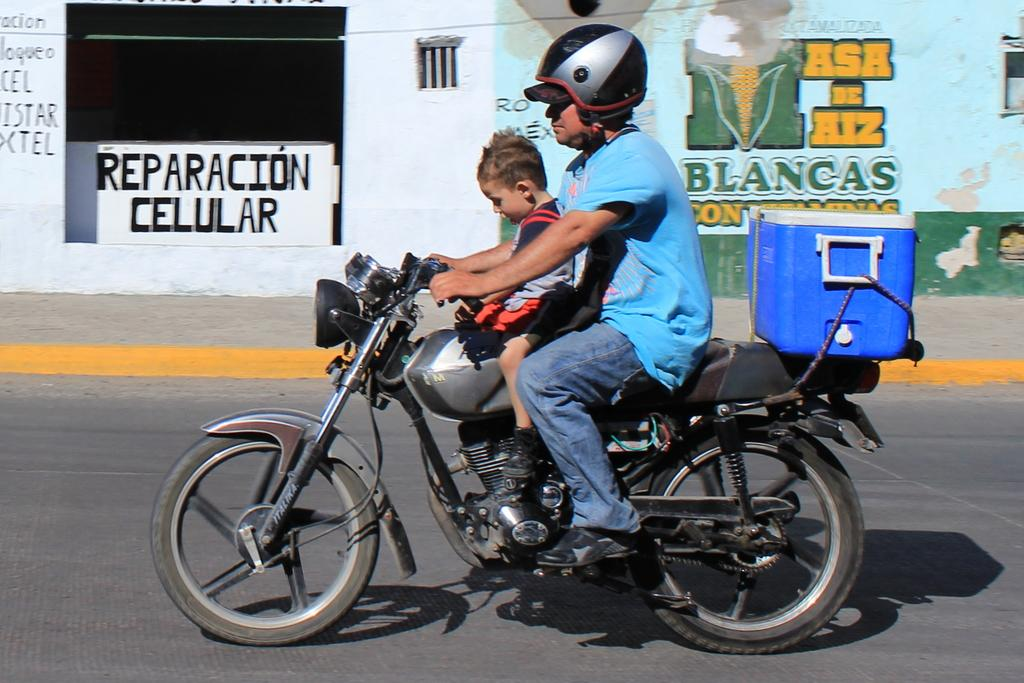Who can be seen in the image? There is a man and a boy in the image. What are they doing in the image? They are moving on a motorcycle. Where is the motorcycle located? The motorcycle is on the road. What is attached to the motorcycle? There is a box tied to the motorcycle. What type of jewel can be seen on the motorcycle in the image? There is no jewel present on the motorcycle in the image. 